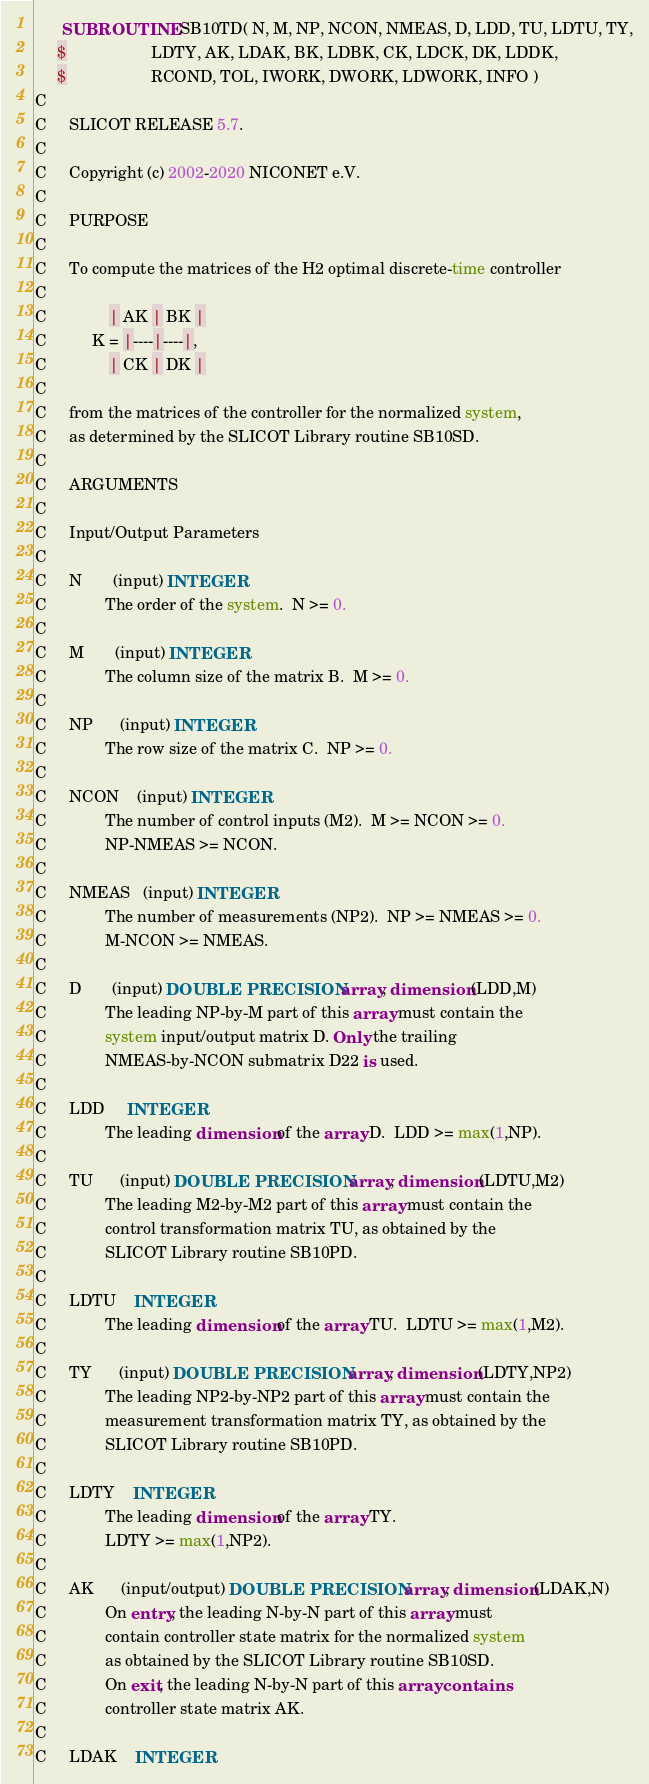<code> <loc_0><loc_0><loc_500><loc_500><_FORTRAN_>      SUBROUTINE SB10TD( N, M, NP, NCON, NMEAS, D, LDD, TU, LDTU, TY,
     $                   LDTY, AK, LDAK, BK, LDBK, CK, LDCK, DK, LDDK,
     $                   RCOND, TOL, IWORK, DWORK, LDWORK, INFO )
C
C     SLICOT RELEASE 5.7.
C
C     Copyright (c) 2002-2020 NICONET e.V.
C
C     PURPOSE
C
C     To compute the matrices of the H2 optimal discrete-time controller
C
C              | AK | BK |
C          K = |----|----|,
C              | CK | DK |
C
C     from the matrices of the controller for the normalized system,
C     as determined by the SLICOT Library routine SB10SD.
C
C     ARGUMENTS
C
C     Input/Output Parameters
C
C     N       (input) INTEGER
C             The order of the system.  N >= 0.
C
C     M       (input) INTEGER
C             The column size of the matrix B.  M >= 0.
C
C     NP      (input) INTEGER
C             The row size of the matrix C.  NP >= 0.
C
C     NCON    (input) INTEGER
C             The number of control inputs (M2).  M >= NCON >= 0.
C             NP-NMEAS >= NCON.
C
C     NMEAS   (input) INTEGER
C             The number of measurements (NP2).  NP >= NMEAS >= 0.
C             M-NCON >= NMEAS.
C
C     D       (input) DOUBLE PRECISION array, dimension (LDD,M)
C             The leading NP-by-M part of this array must contain the
C             system input/output matrix D. Only the trailing
C             NMEAS-by-NCON submatrix D22 is used.
C
C     LDD     INTEGER
C             The leading dimension of the array D.  LDD >= max(1,NP).
C
C     TU      (input) DOUBLE PRECISION array, dimension (LDTU,M2)
C             The leading M2-by-M2 part of this array must contain the
C             control transformation matrix TU, as obtained by the
C             SLICOT Library routine SB10PD.
C
C     LDTU    INTEGER
C             The leading dimension of the array TU.  LDTU >= max(1,M2).
C
C     TY      (input) DOUBLE PRECISION array, dimension (LDTY,NP2)
C             The leading NP2-by-NP2 part of this array must contain the
C             measurement transformation matrix TY, as obtained by the
C             SLICOT Library routine SB10PD.
C
C     LDTY    INTEGER
C             The leading dimension of the array TY.
C             LDTY >= max(1,NP2).
C
C     AK      (input/output) DOUBLE PRECISION array, dimension (LDAK,N)
C             On entry, the leading N-by-N part of this array must
C             contain controller state matrix for the normalized system
C             as obtained by the SLICOT Library routine SB10SD.
C             On exit, the leading N-by-N part of this array contains
C             controller state matrix AK.
C
C     LDAK    INTEGER</code> 